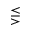Convert formula to latex. <formula><loc_0><loc_0><loc_500><loc_500>\leq s s e q g t r</formula> 